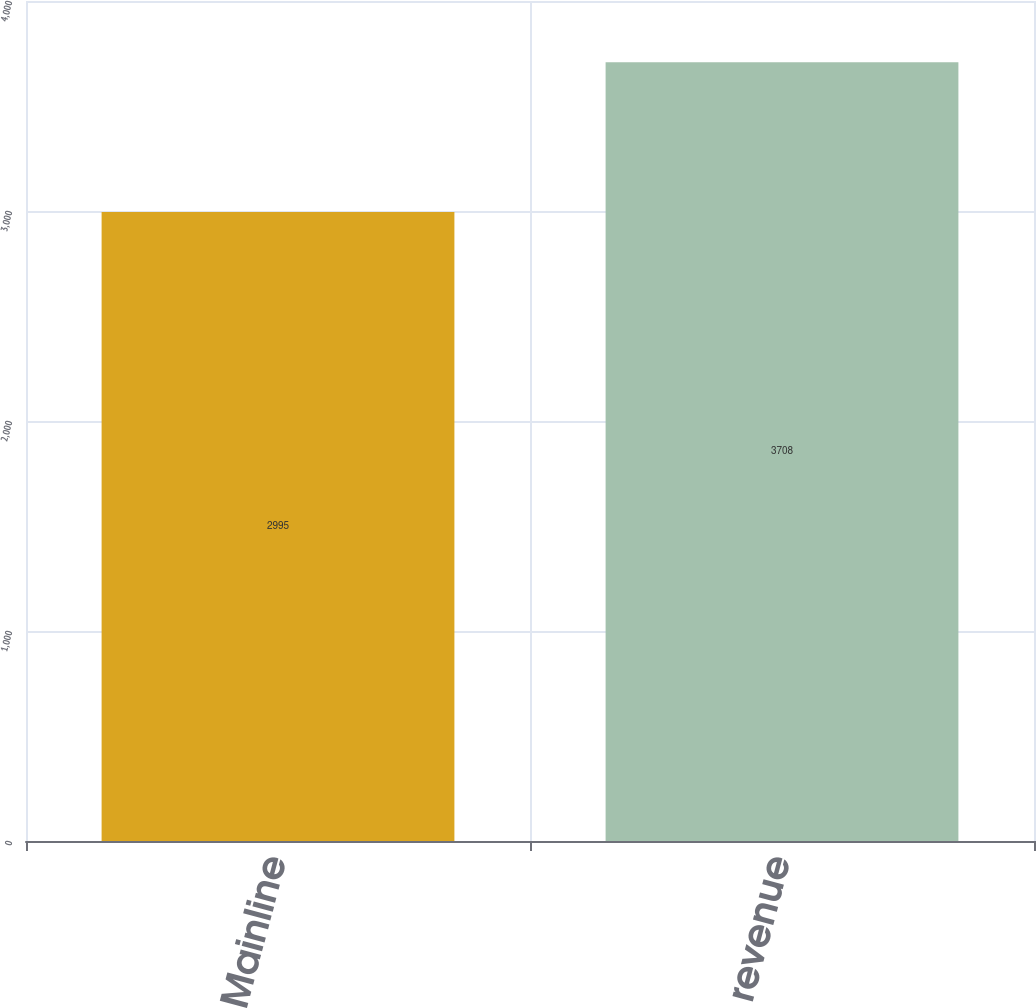Convert chart. <chart><loc_0><loc_0><loc_500><loc_500><bar_chart><fcel>Mainline<fcel>revenue<nl><fcel>2995<fcel>3708<nl></chart> 